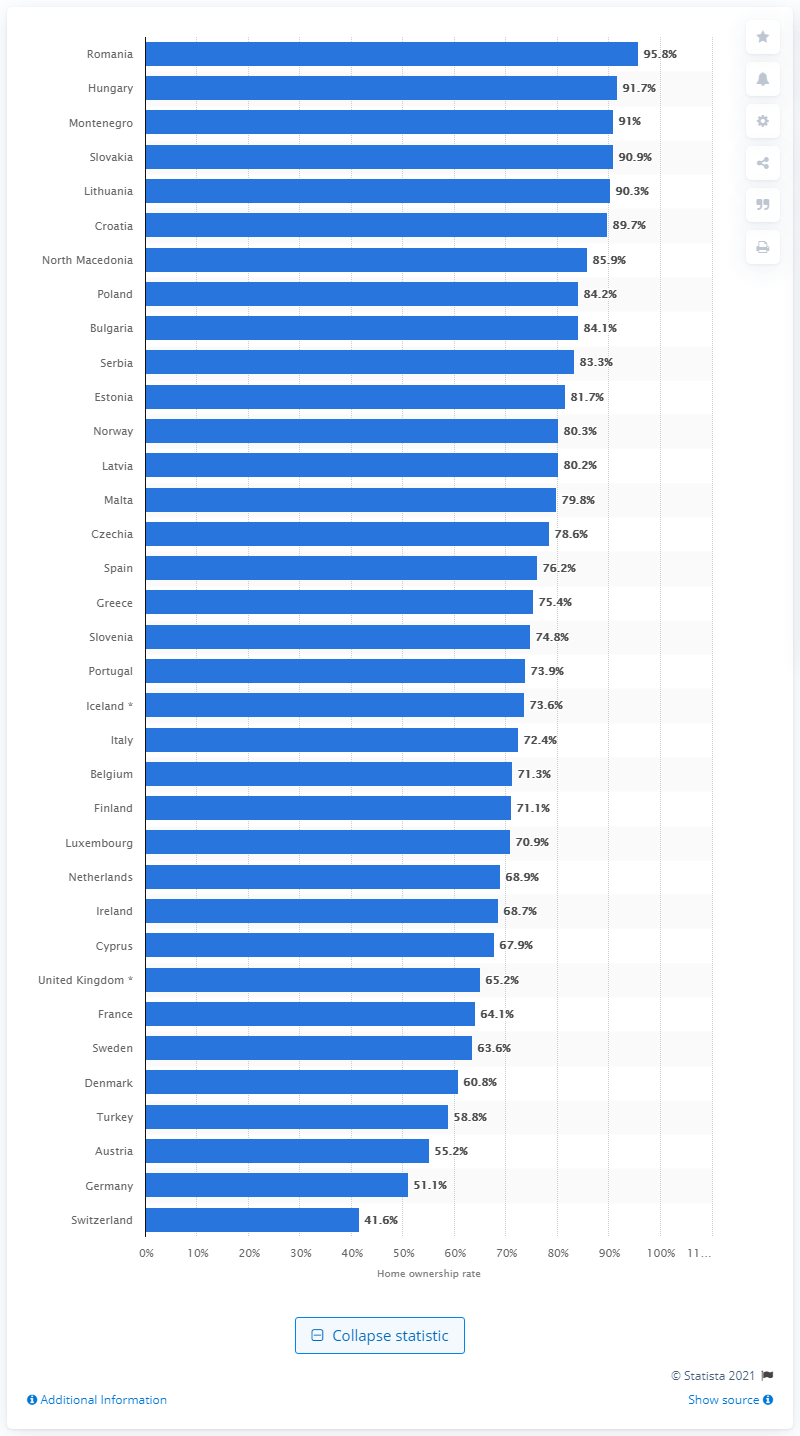Mention a couple of crucial points in this snapshot. According to data, the home ownership rate in Switzerland was 41.6% in 2020. The home ownership rate in Romania is 95.8%. 